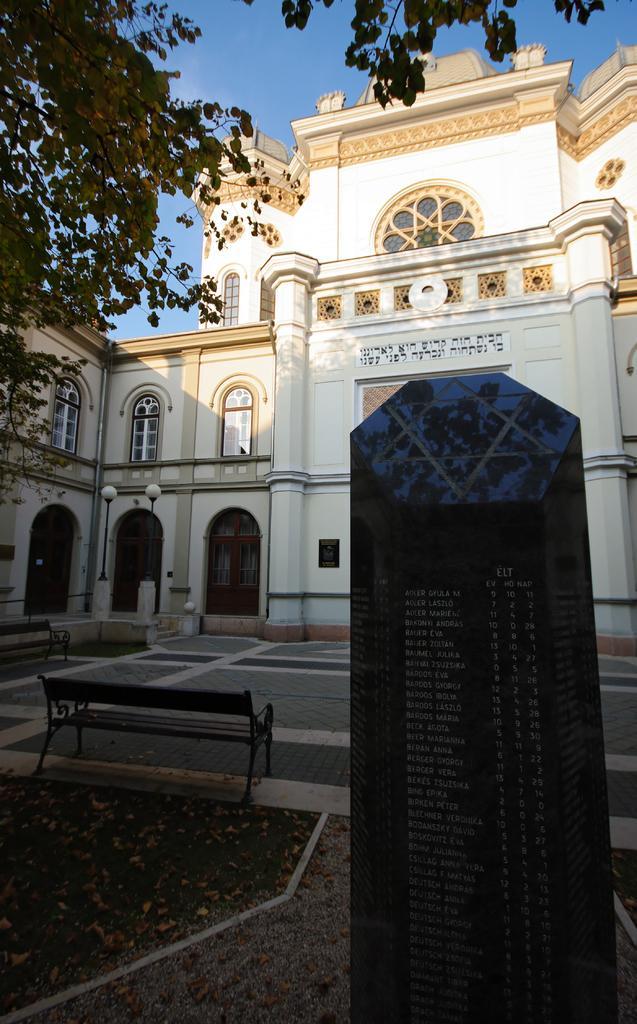Could you give a brief overview of what you see in this image? In this picture we can see a black color carved stone in the front, there is some text on the stone, at the left bottom we can see grass, leaves and a bench, on the left side there is a tree, in the background we can see a building, two poles and lights, there is the sky at the top of the picture. 